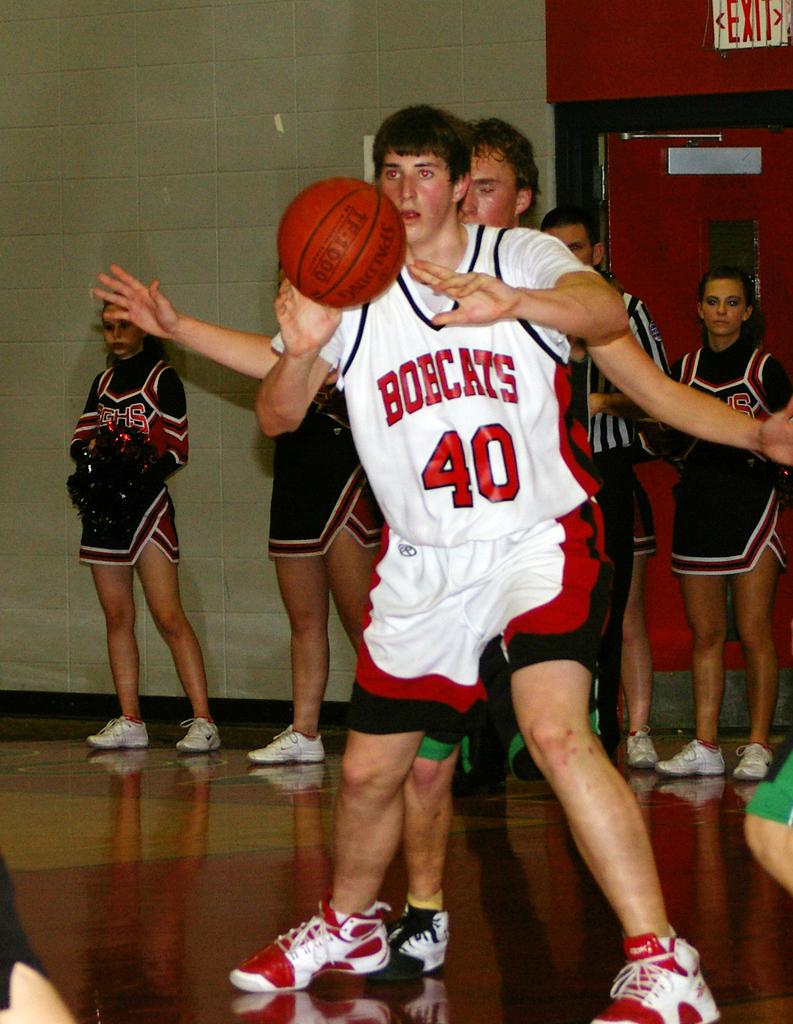What does the white and  red sing on top of the door say?
Make the answer very short. Exit. 